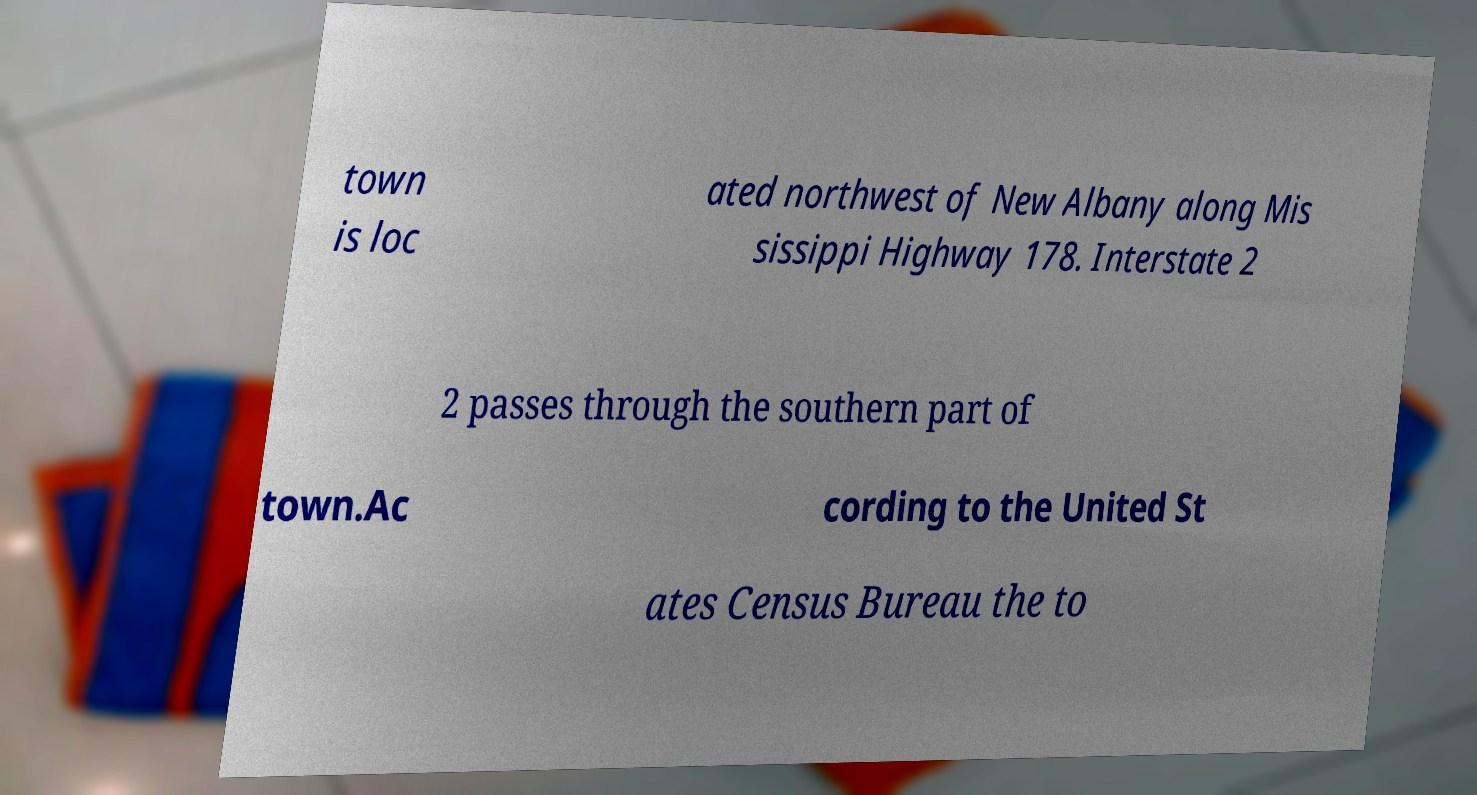Could you extract and type out the text from this image? town is loc ated northwest of New Albany along Mis sissippi Highway 178. Interstate 2 2 passes through the southern part of town.Ac cording to the United St ates Census Bureau the to 